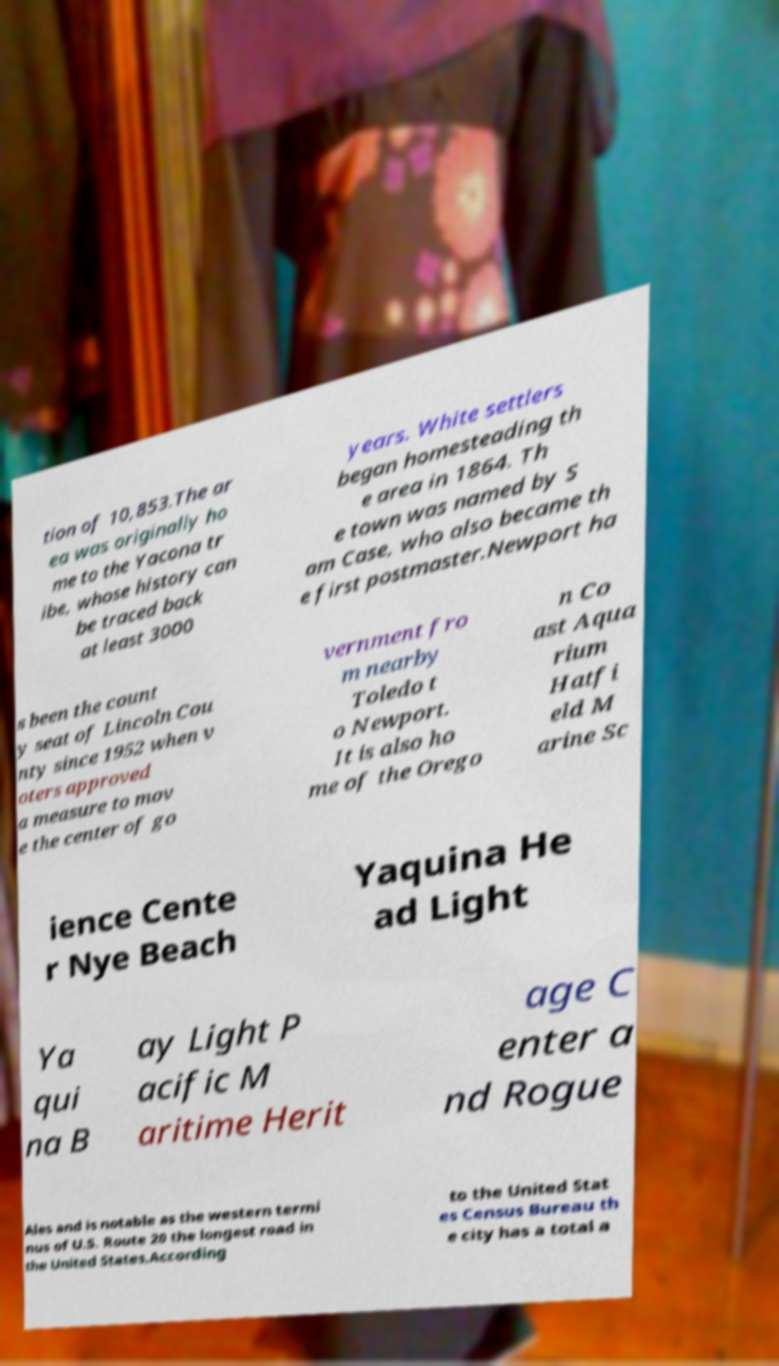For documentation purposes, I need the text within this image transcribed. Could you provide that? tion of 10,853.The ar ea was originally ho me to the Yacona tr ibe, whose history can be traced back at least 3000 years. White settlers began homesteading th e area in 1864. Th e town was named by S am Case, who also became th e first postmaster.Newport ha s been the count y seat of Lincoln Cou nty since 1952 when v oters approved a measure to mov e the center of go vernment fro m nearby Toledo t o Newport. It is also ho me of the Orego n Co ast Aqua rium Hatfi eld M arine Sc ience Cente r Nye Beach Yaquina He ad Light Ya qui na B ay Light P acific M aritime Herit age C enter a nd Rogue Ales and is notable as the western termi nus of U.S. Route 20 the longest road in the United States.According to the United Stat es Census Bureau th e city has a total a 